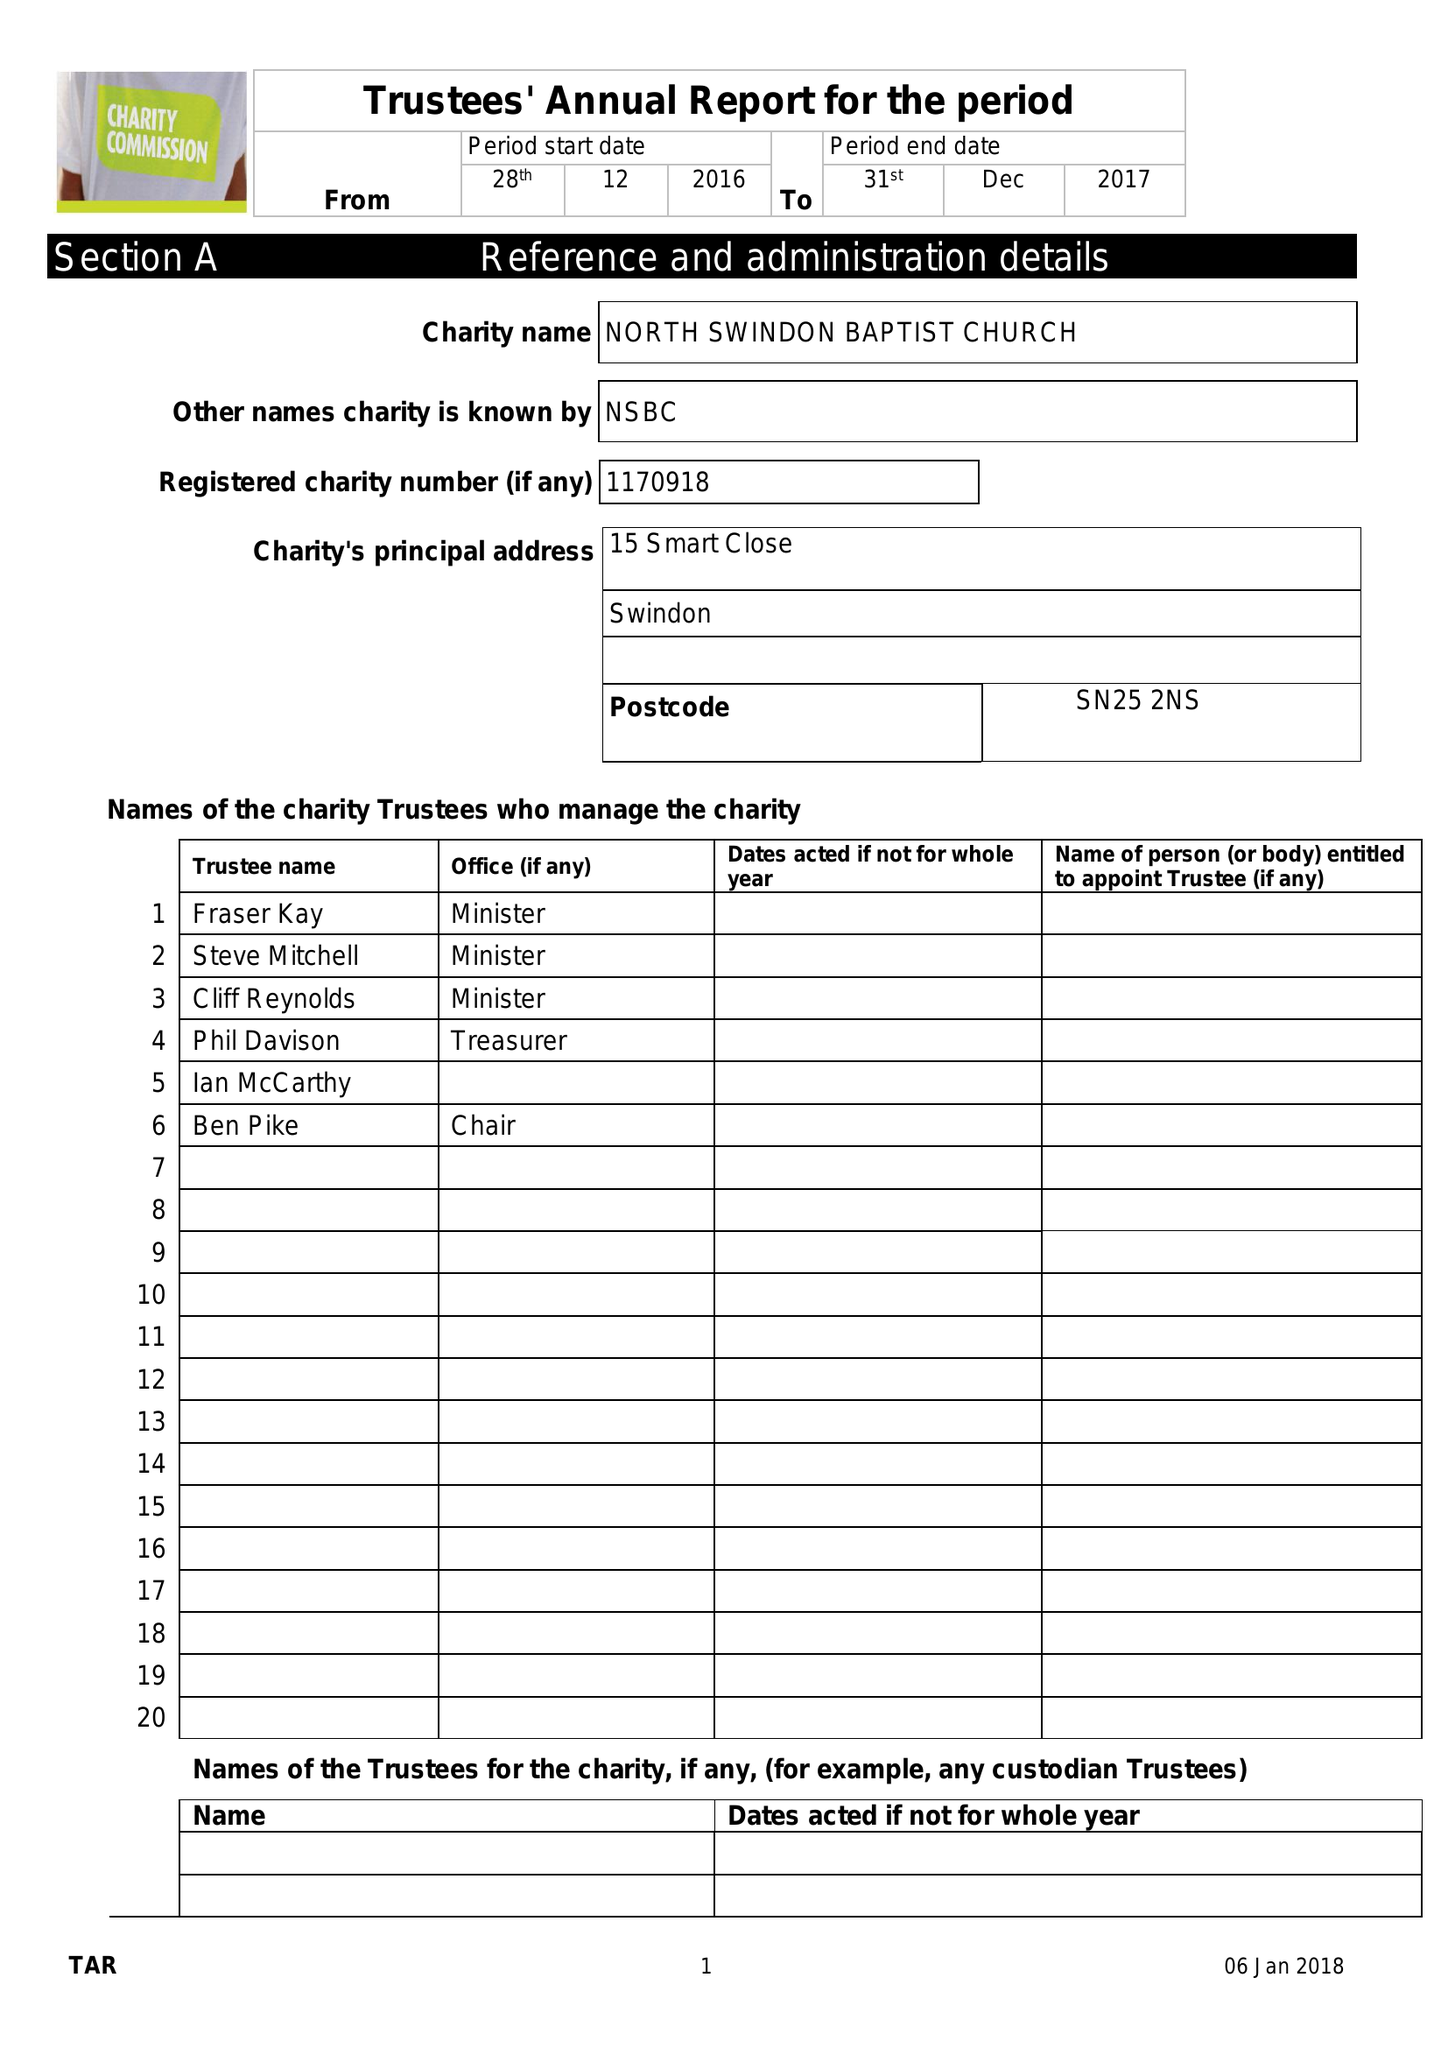What is the value for the income_annually_in_british_pounds?
Answer the question using a single word or phrase. 109566.00 